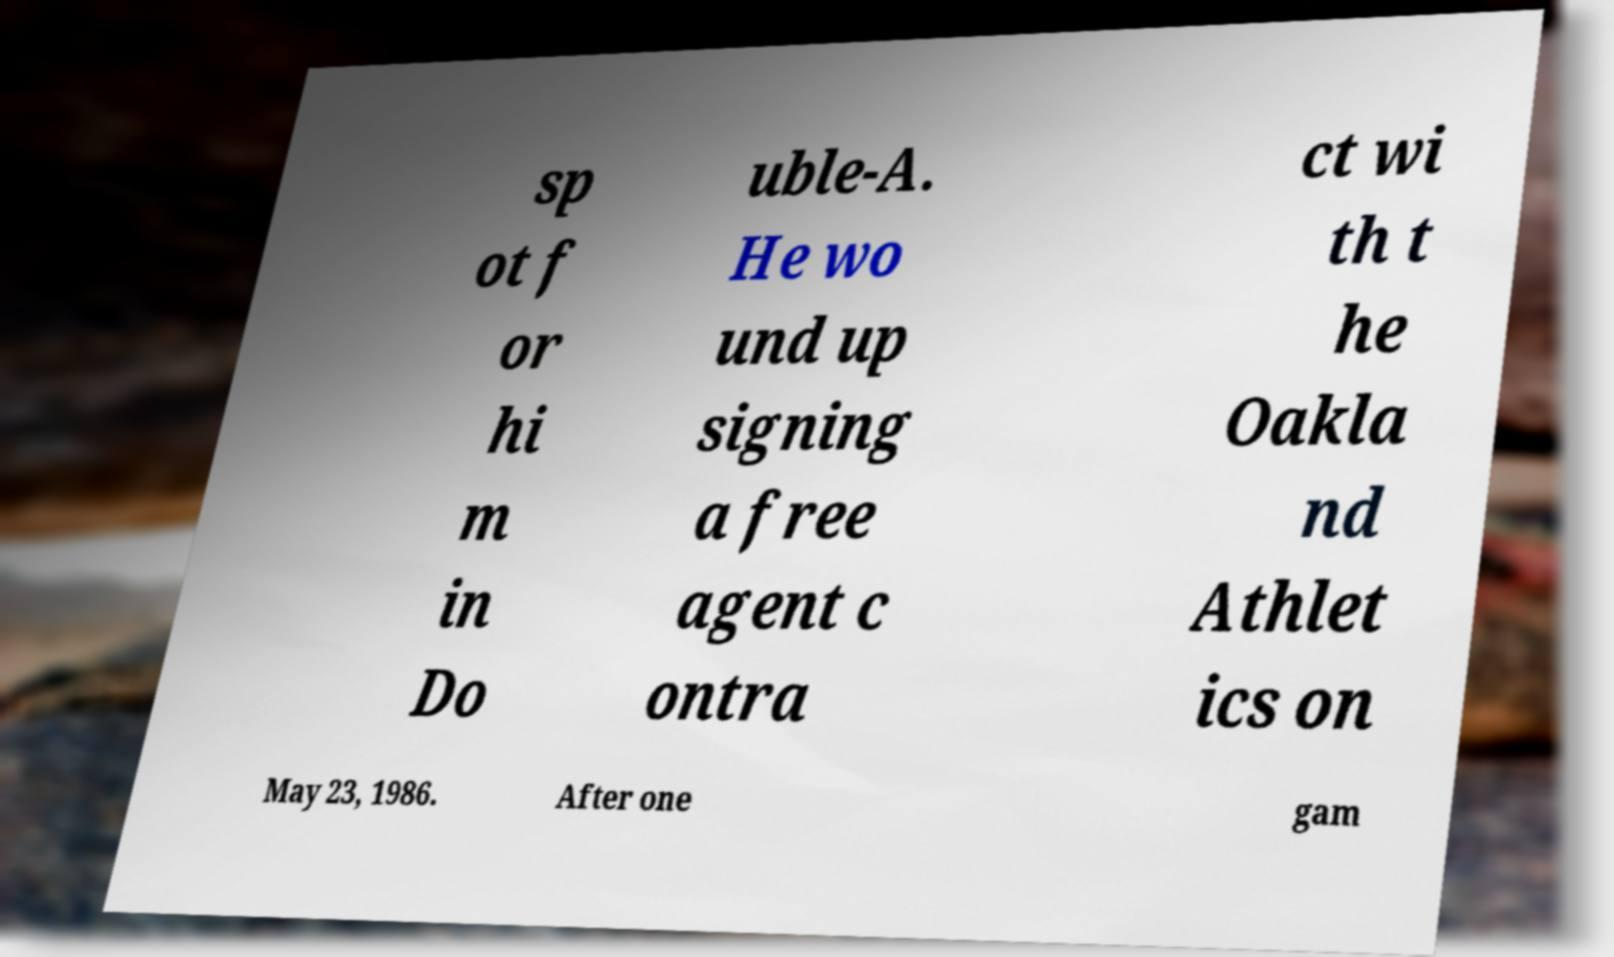Can you accurately transcribe the text from the provided image for me? sp ot f or hi m in Do uble-A. He wo und up signing a free agent c ontra ct wi th t he Oakla nd Athlet ics on May 23, 1986. After one gam 